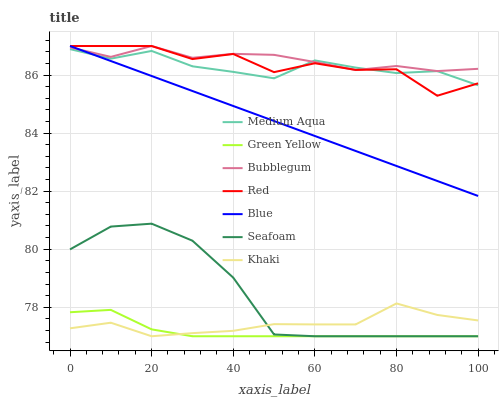Does Green Yellow have the minimum area under the curve?
Answer yes or no. Yes. Does Bubblegum have the maximum area under the curve?
Answer yes or no. Yes. Does Khaki have the minimum area under the curve?
Answer yes or no. No. Does Khaki have the maximum area under the curve?
Answer yes or no. No. Is Blue the smoothest?
Answer yes or no. Yes. Is Red the roughest?
Answer yes or no. Yes. Is Khaki the smoothest?
Answer yes or no. No. Is Khaki the roughest?
Answer yes or no. No. Does Khaki have the lowest value?
Answer yes or no. Yes. Does Bubblegum have the lowest value?
Answer yes or no. No. Does Red have the highest value?
Answer yes or no. Yes. Does Khaki have the highest value?
Answer yes or no. No. Is Green Yellow less than Blue?
Answer yes or no. Yes. Is Red greater than Green Yellow?
Answer yes or no. Yes. Does Blue intersect Bubblegum?
Answer yes or no. Yes. Is Blue less than Bubblegum?
Answer yes or no. No. Is Blue greater than Bubblegum?
Answer yes or no. No. Does Green Yellow intersect Blue?
Answer yes or no. No. 